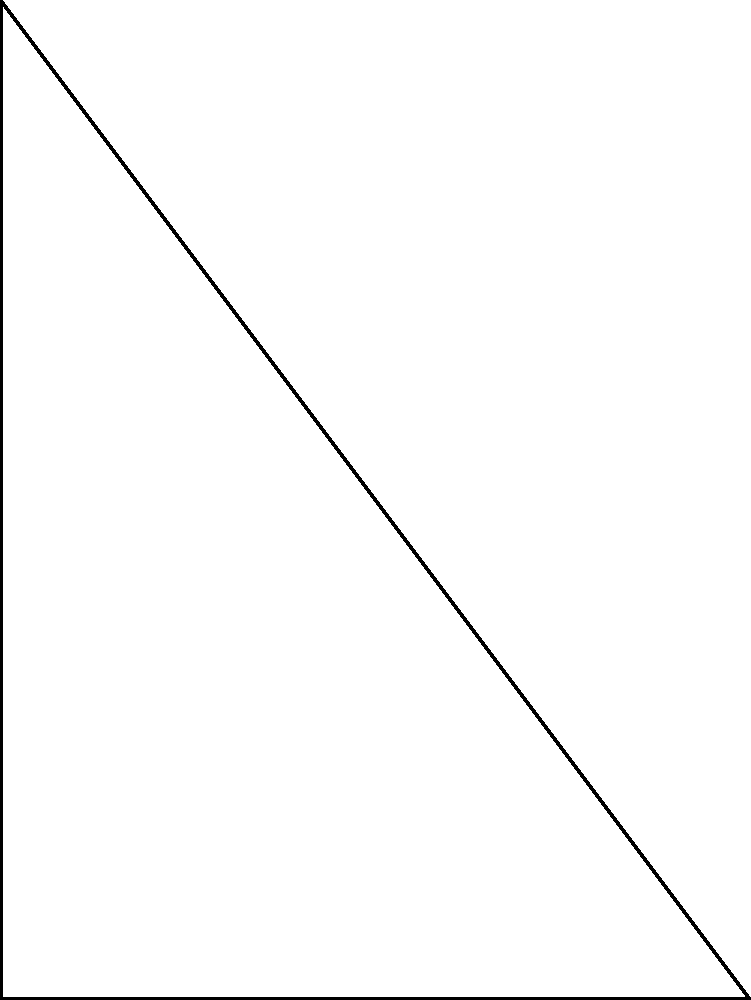As a firefighter's spouse, you're familiar with ladder operations. A 50-meter ladder is leaned against a burning building, reaching a height of 40 meters. The ladder's base is 30 meters from the building. What is the angle $\theta$ (in degrees) between the ladder and the ground? Let's approach this step-by-step:

1) We have a right-angled triangle where:
   - The ladder is the hypotenuse
   - The height of the building (40 m) is the opposite side
   - The distance from the building to the ladder's base (30 m) is the adjacent side

2) To find the angle $\theta$, we can use the tangent function:

   $$\tan \theta = \frac{\text{opposite}}{\text{adjacent}} = \frac{40}{30}$$

3) To get $\theta$, we need to use the inverse tangent (arctan or $\tan^{-1}$):

   $$\theta = \tan^{-1}\left(\frac{40}{30}\right)$$

4) Using a calculator or computer:

   $$\theta \approx 53.13^\circ$$

5) Rounding to the nearest degree:

   $$\theta \approx 53^\circ$$

Note: We didn't need to use the ladder's length (50 m) for this calculation, but we could verify our answer using the Pythagorean theorem if needed.
Answer: $53^\circ$ 